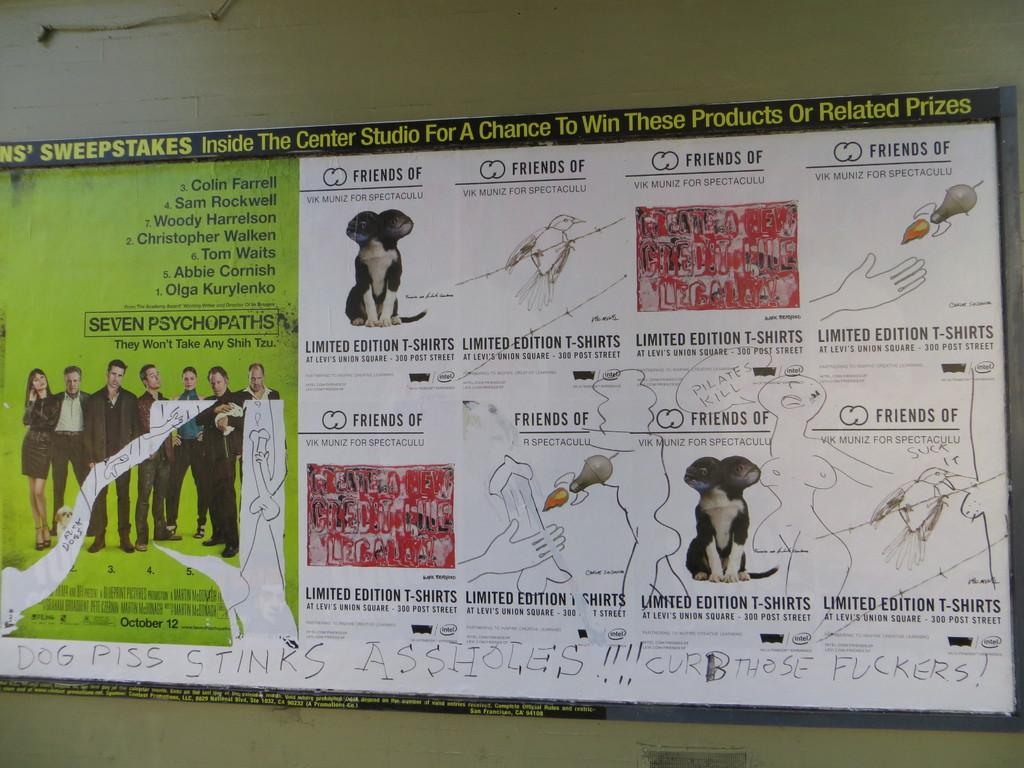<image>
Provide a brief description of the given image. A sign on a wall is torn and has graffiti, some of it pornographic and references the smell of dog urine. 